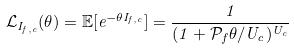<formula> <loc_0><loc_0><loc_500><loc_500>\mathcal { L } _ { I _ { f , c } } ( \theta ) = \mathbb { E } [ e ^ { - \theta I _ { f , c } } ] = \frac { 1 } { ( 1 + \mathcal { P } _ { f } \theta / U _ { c } ) ^ { U _ { c } } }</formula> 